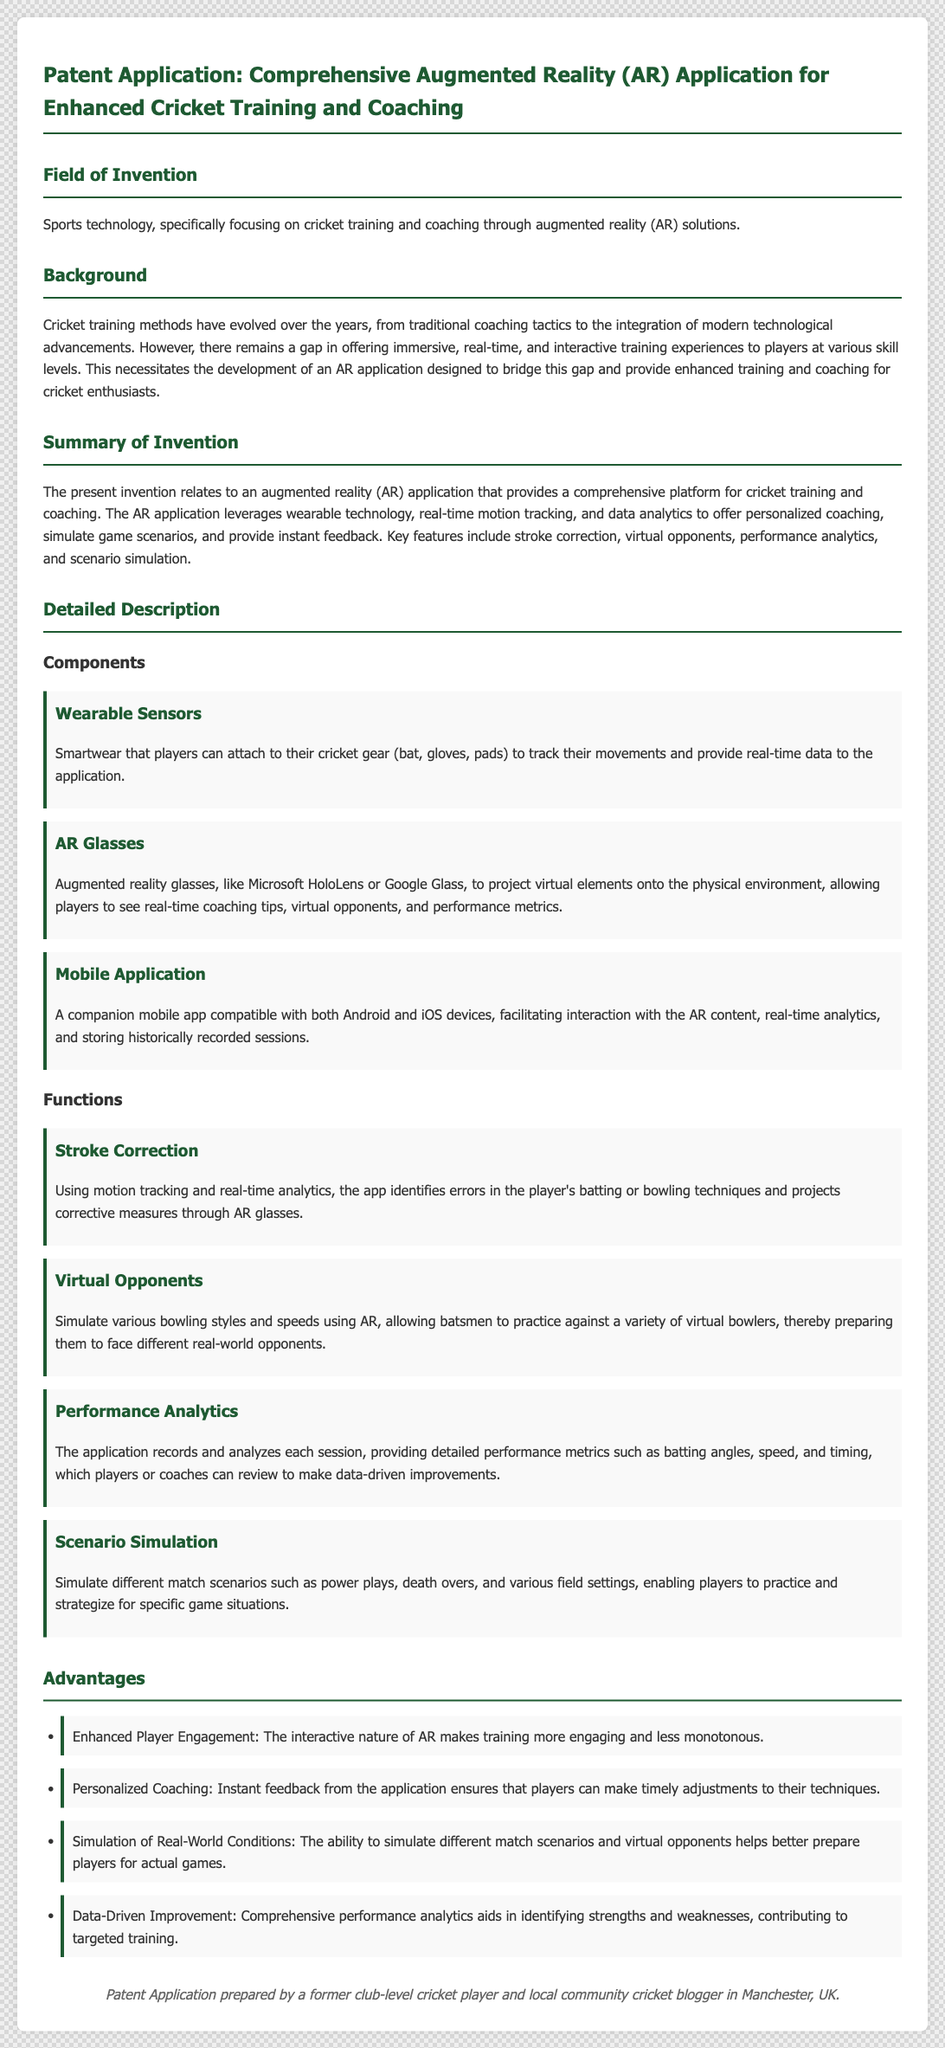What is the field of invention? The field of invention is indicated in the document as "sports technology, specifically focusing on cricket training and coaching through augmented reality (AR) solutions."
Answer: sports technology What features does the AR application offer? The document summarizes key features offered by the AR application such as stroke correction, virtual opponents, performance analytics, and scenario simulation.
Answer: stroke correction, virtual opponents, performance analytics, scenario simulation What technologies are mentioned in the components section? In the components section, the document mentions wearable sensors, AR glasses, and a mobile application.
Answer: wearable sensors, AR glasses, mobile application How many functions of the application are described? The document describes four distinct functions of the AR application aimed at enhancing cricket training.
Answer: four What advantage is related to player engagement? The document states that the interactive nature of AR enhances player engagement by making training more engaging and less monotonous.
Answer: Enhanced Player Engagement What type of data does the performance analytics function provide? The performance analytics function in the document provides detailed performance metrics such as batting angles, speed, and timing.
Answer: batting angles, speed, timing Who prepared the patent application? The footer section of the document informs that the patent application was prepared by a former club-level cricket player and local community cricket blogger in Manchester, UK.
Answer: a former club-level cricket player What gap does the invention aim to bridge? The background section highlights the gap that the invention aims to bridge, which is the lack of immersive, real-time, and interactive training experiences for players.
Answer: immersive, real-time, and interactive training experiences 